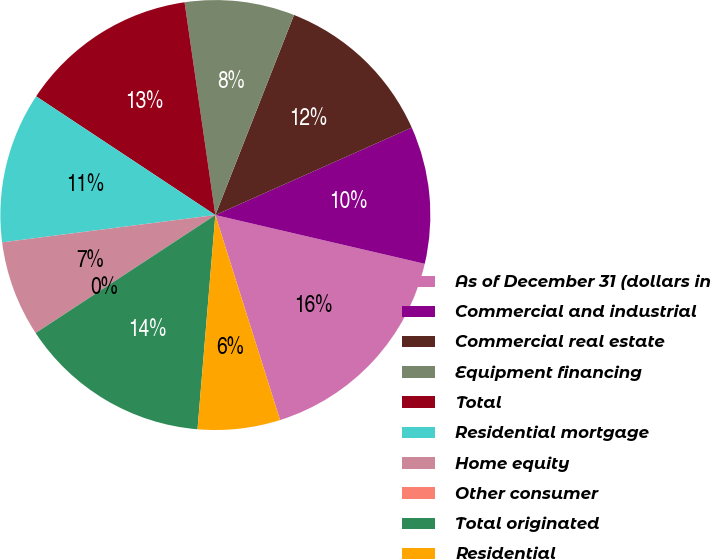<chart> <loc_0><loc_0><loc_500><loc_500><pie_chart><fcel>As of December 31 (dollars in<fcel>Commercial and industrial<fcel>Commercial real estate<fcel>Equipment financing<fcel>Total<fcel>Residential mortgage<fcel>Home equity<fcel>Other consumer<fcel>Total originated<fcel>Residential<nl><fcel>16.49%<fcel>10.31%<fcel>12.37%<fcel>8.25%<fcel>13.4%<fcel>11.34%<fcel>7.22%<fcel>0.0%<fcel>14.43%<fcel>6.19%<nl></chart> 